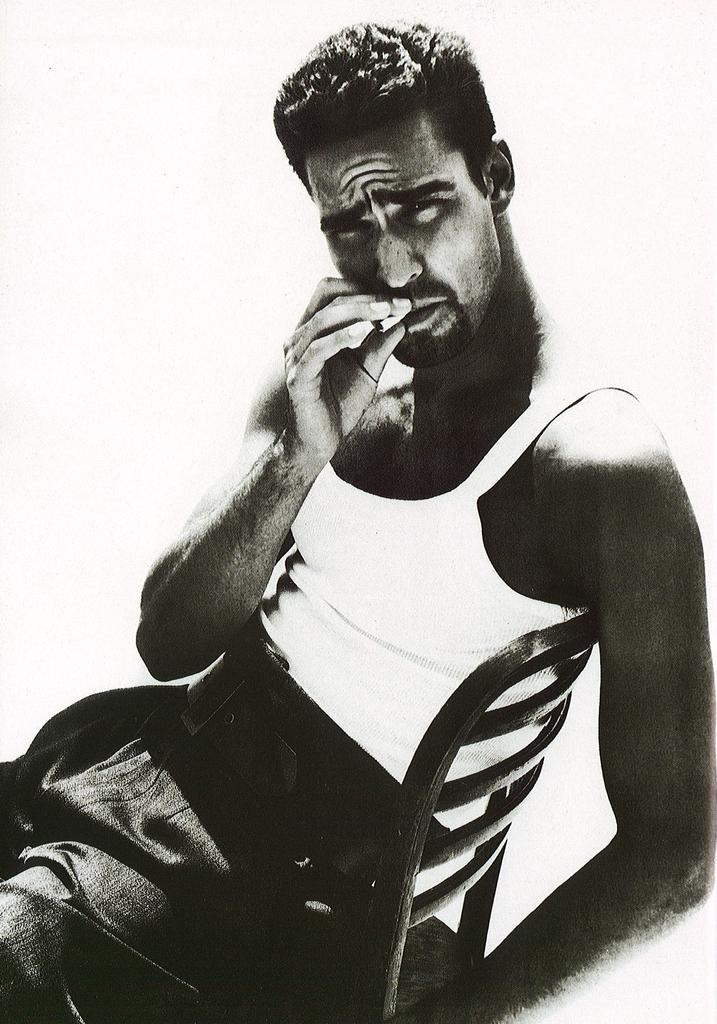What is the color scheme of the image? The image is black and white. Can you describe the person in the image? There is a person in the image, and they are sitting on a chair. What is the person holding in their hand? The person is holding an object in their hand. Is there an earthquake happening in the image? No, there is no indication of an earthquake in the image. 